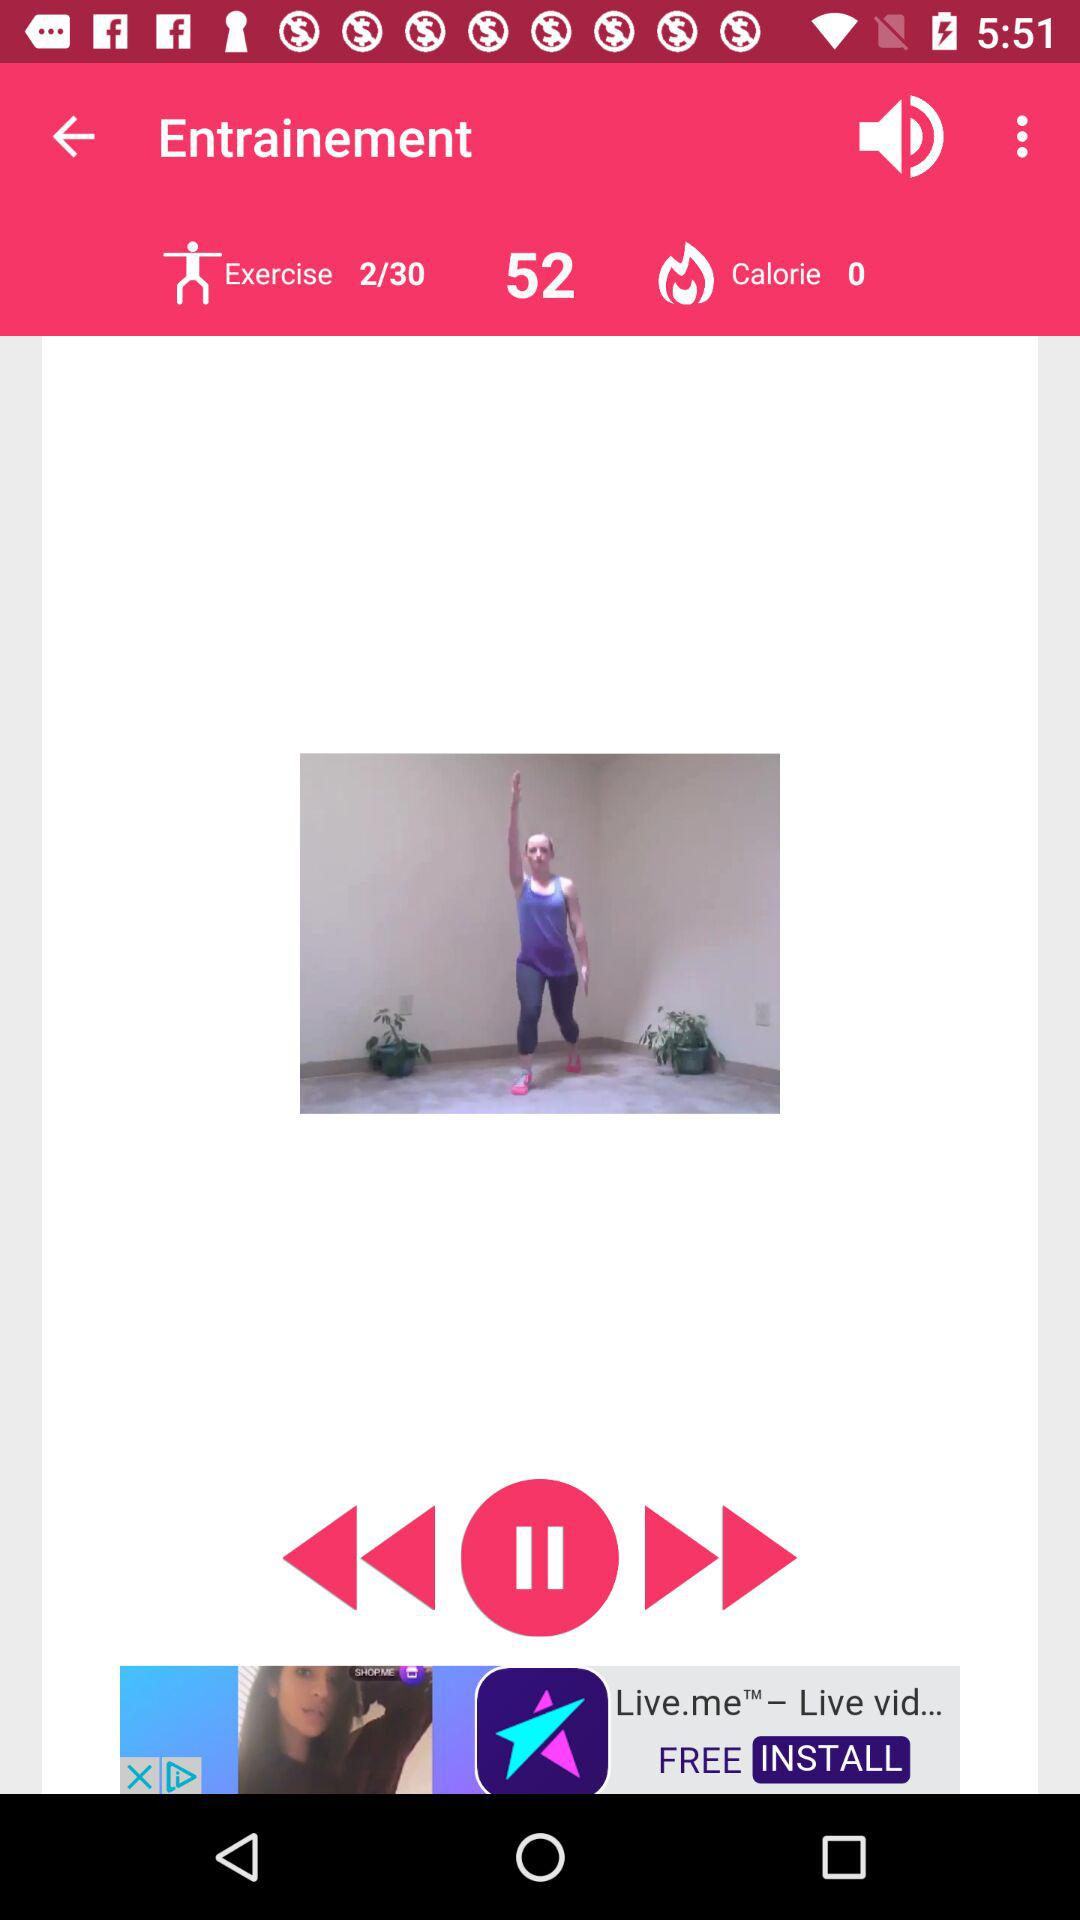At which exercise am I? You are at exercise 2. 